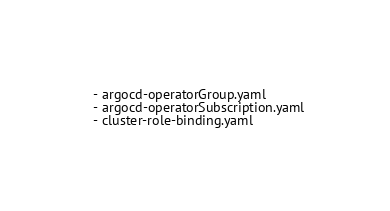<code> <loc_0><loc_0><loc_500><loc_500><_YAML_>  - argocd-operatorGroup.yaml
  - argocd-operatorSubscription.yaml
  - cluster-role-binding.yaml
</code> 